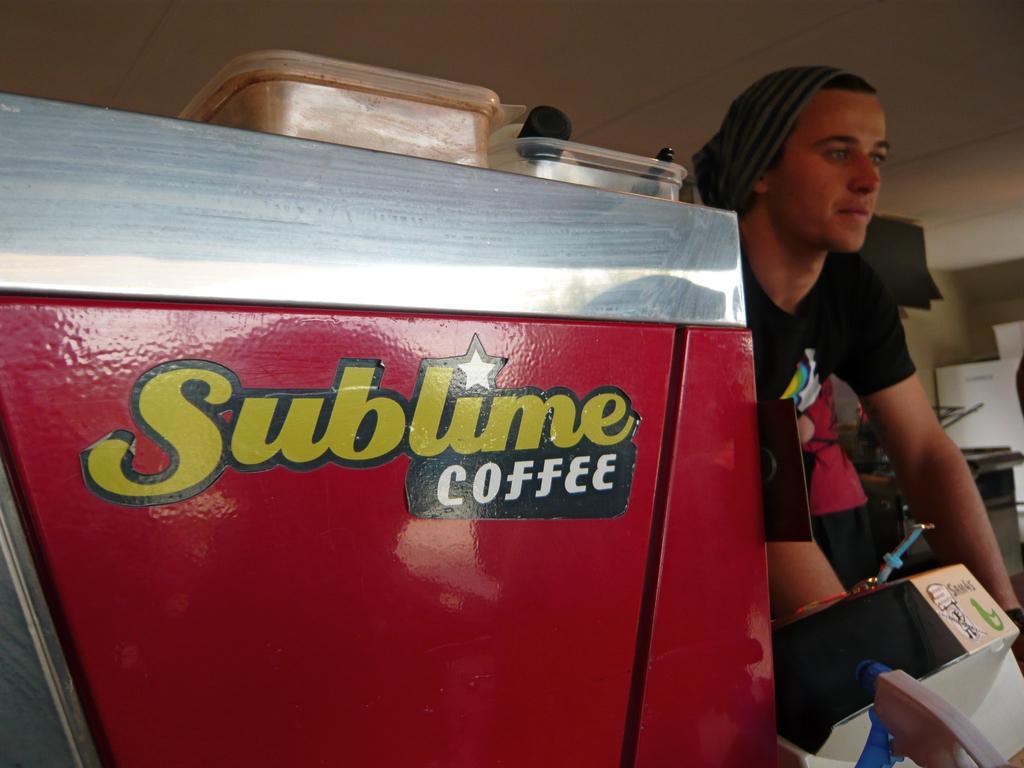Describe this image in one or two sentences. In this picture I can observe a man on the right side. He is wearing black color T shirt. I can observe two plastic boxes placed on the coffee vending machine which is in red color. 